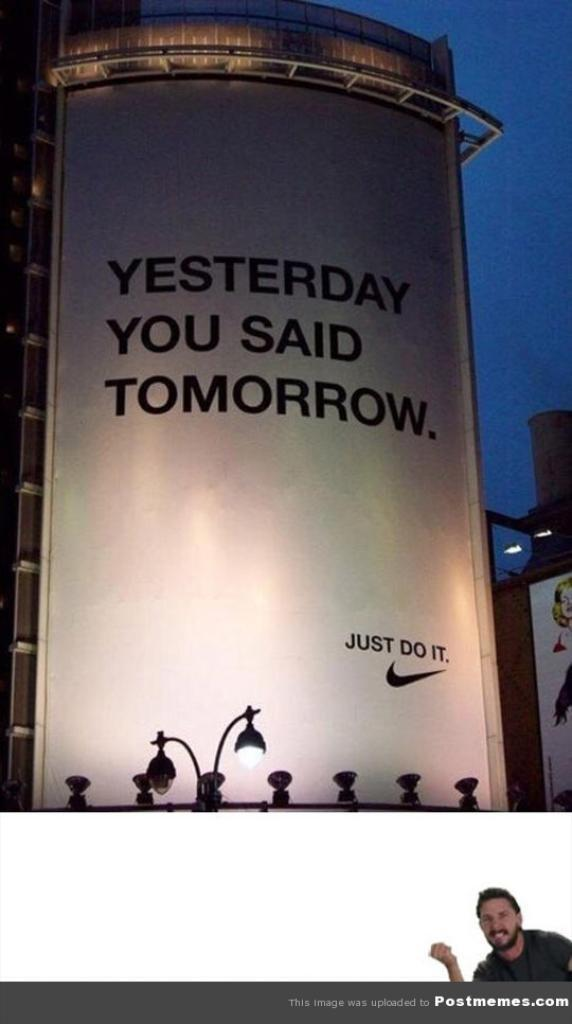What is the main subject of the image? The main subject of the image is the front view of a building. Are there any objects or features in front of the building? Yes, there is a light pole in front of the building. Can you describe the presence of a person in the image? A person is present at the bottom of the image. Is there any additional information about the image itself? The image has a watermark. What type of flowers can be seen growing on the roof of the building in the image? There are no flowers visible on the roof of the building in the image. How many birds are perched on the light pole in the image? There are no birds present in the image. 